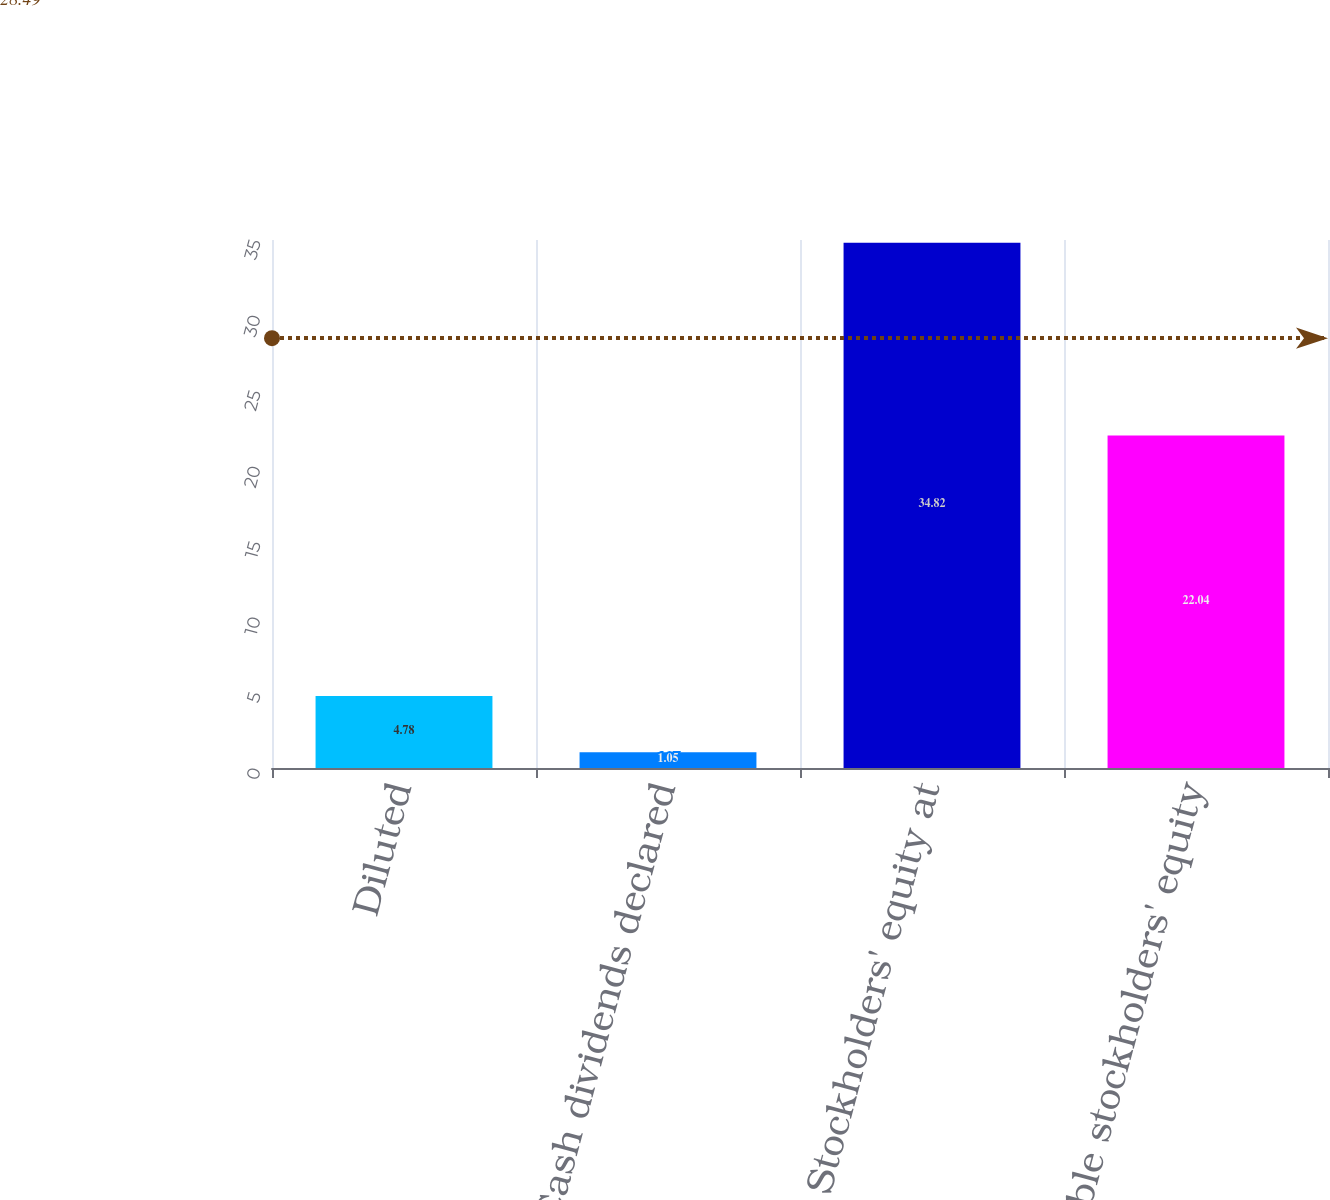<chart> <loc_0><loc_0><loc_500><loc_500><bar_chart><fcel>Diluted<fcel>Cash dividends declared<fcel>Stockholders' equity at<fcel>Tangible stockholders' equity<nl><fcel>4.78<fcel>1.05<fcel>34.82<fcel>22.04<nl></chart> 